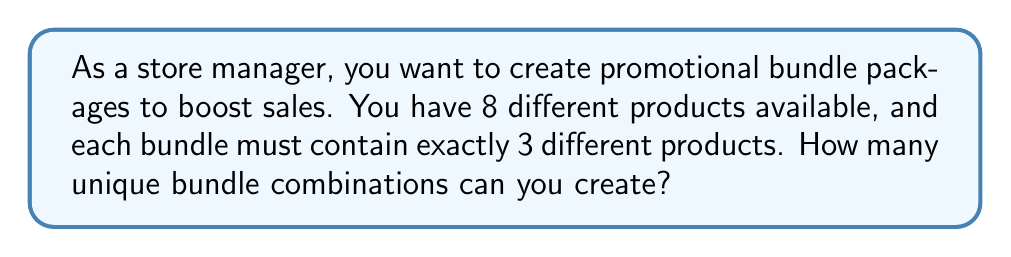Can you answer this question? Let's approach this step-by-step:

1) This is a combination problem. We are selecting 3 items from a set of 8, where the order doesn't matter (because it's a bundle, not an ordered list).

2) The formula for combinations is:

   $$C(n,r) = \frac{n!}{r!(n-r)!}$$

   where $n$ is the total number of items to choose from, and $r$ is the number of items being chosen.

3) In this case, $n = 8$ (total products) and $r = 3$ (products per bundle).

4) Let's substitute these values into our formula:

   $$C(8,3) = \frac{8!}{3!(8-3)!} = \frac{8!}{3!5!}$$

5) Expand this:
   $$\frac{8 \times 7 \times 6 \times 5!}{(3 \times 2 \times 1) \times 5!}$$

6) The 5! cancels out in the numerator and denominator:

   $$\frac{8 \times 7 \times 6}{3 \times 2 \times 1} = \frac{336}{6} = 56$$

Therefore, you can create 56 unique bundle combinations.
Answer: 56 